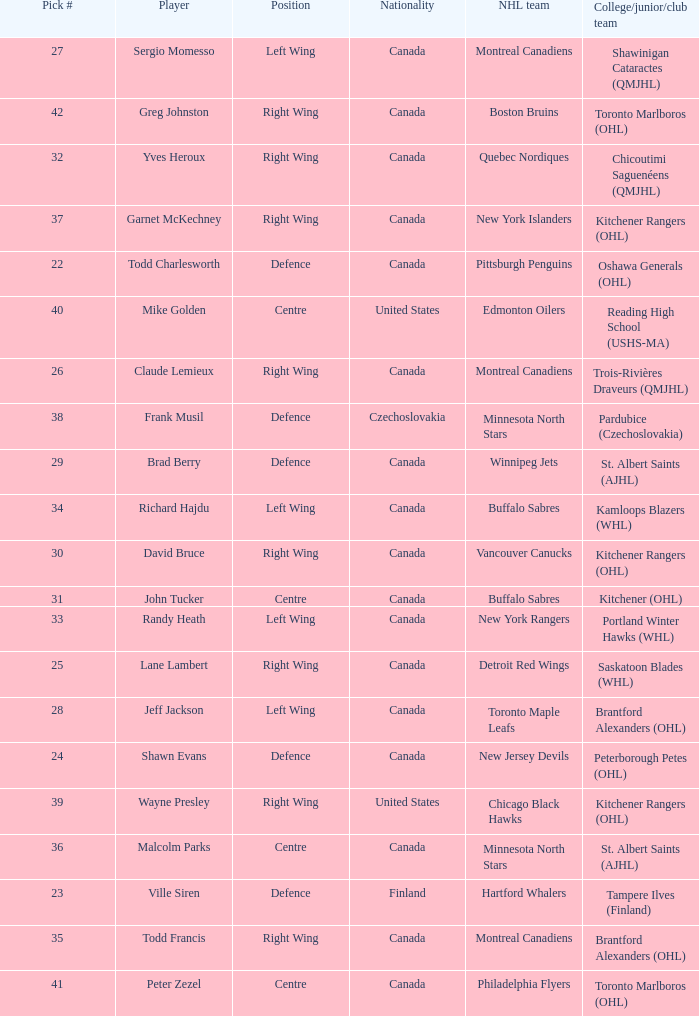What is the position for the nhl team toronto maple leafs? Left Wing. 